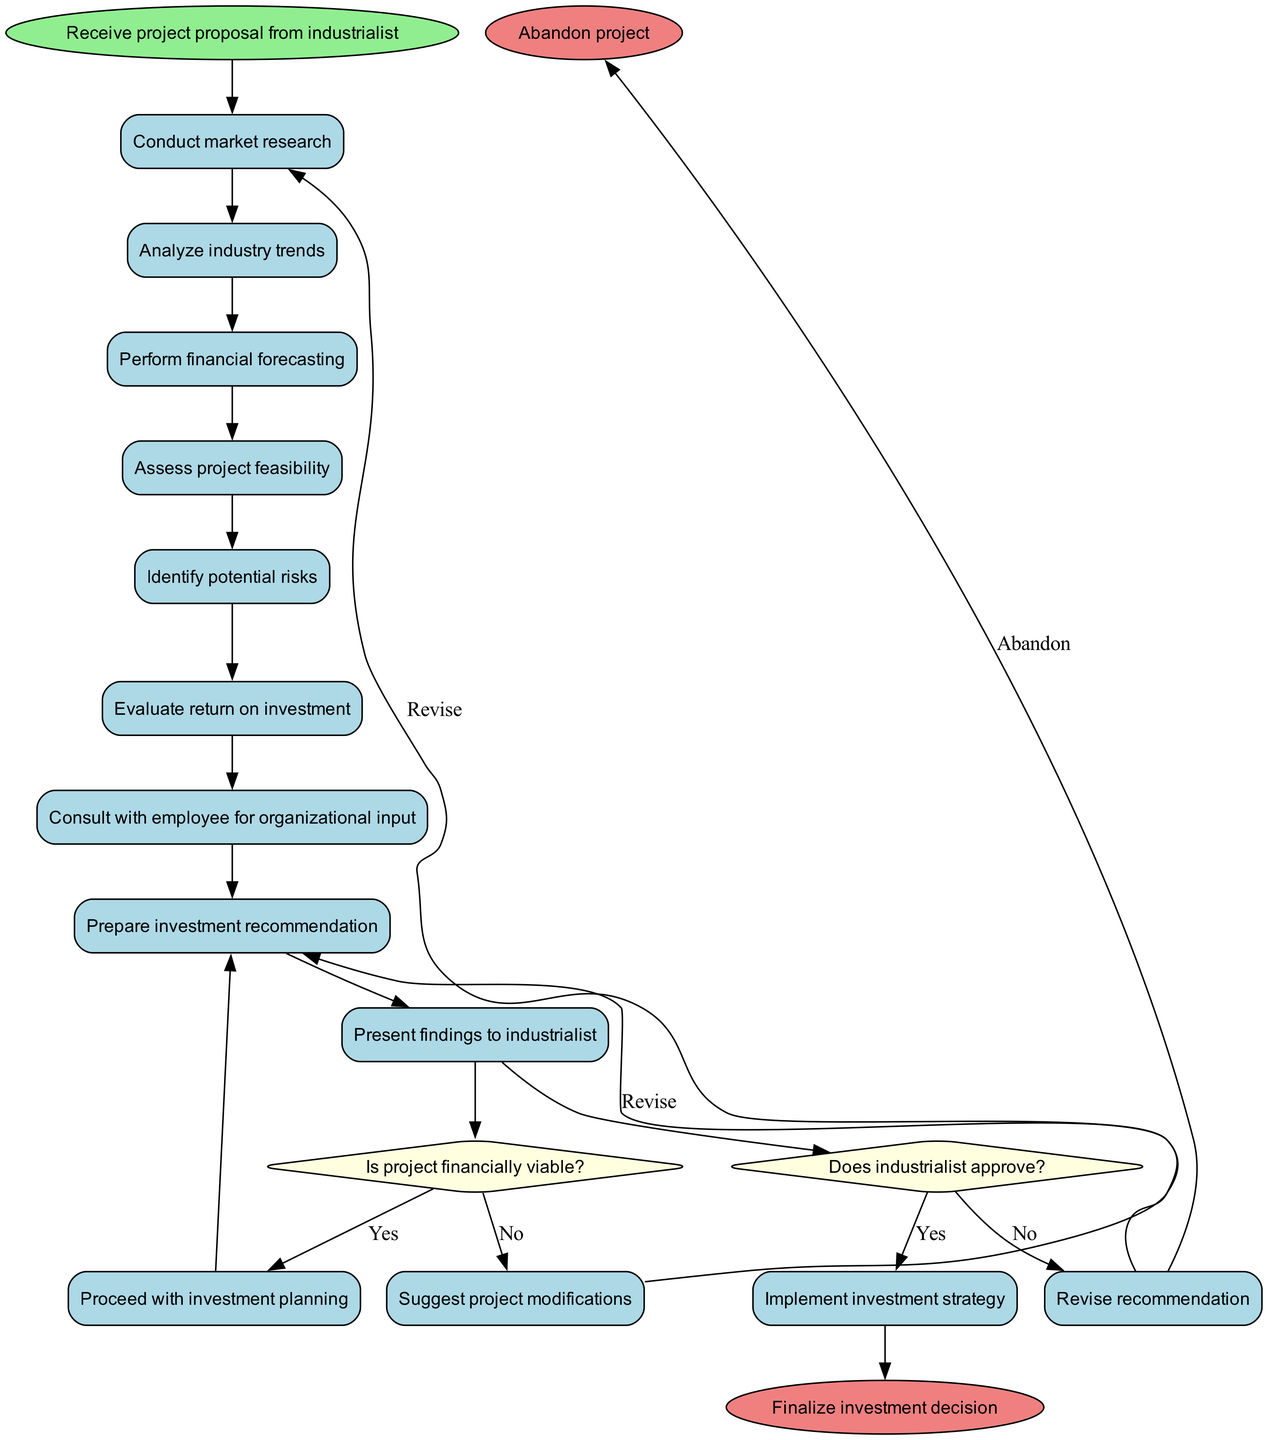What is the starting point of the diagram? The diagram begins with the node labeled "Receive project proposal from industrialist," which is the starting point or the initial action in the process.
Answer: Receive project proposal from industrialist How many activities are depicted in the diagram? The diagram includes a total of nine activities, which are listed in the "activities" section of the data.
Answer: 9 What happens if the project is not financially viable? If the project is not financially viable, the diagram indicates that the next step is to "Suggest project modifications," based on the decision node's "no" outcome.
Answer: Suggest project modifications What is the outcome if the industrialist does not approve the investment? The diagram states that if the industrialist does not approve the investment, the process leads to revising the recommendation. This is shown in the second decision node.
Answer: Revise recommendation Which activity comes after assessing project feasibility? Following the "Assess project feasibility" activity, the next activity depicted is "Identify potential risks," showing a sequential relationship between these two activities.
Answer: Identify potential risks What decision is made after evaluating return on investment? After "Evaluate return on investment," the next decision node is encountered, where a choice must be made regarding whether the project is financially viable or not.
Answer: Is project financially viable? What color is used for the decision nodes in the diagram? The decision nodes are colored light yellow, as indicated by the node style attributes in the diagram setup.
Answer: Light yellow What leads to finalizing the investment decision? The process leads to finalizing the investment decision if the industrialist approves the recommendation after the necessary evaluations and consultations, as shown in the diagram flow.
Answer: Industrialist approval What is the action taken if the project is feasible? If the project is deemed feasible, the next action is to "Prepare investment recommendation," which follows the assessment of project feasibility.
Answer: Prepare investment recommendation 